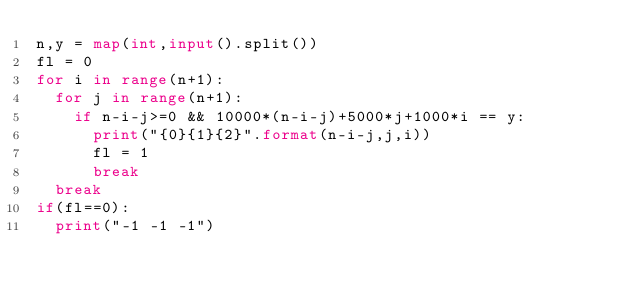Convert code to text. <code><loc_0><loc_0><loc_500><loc_500><_Python_>n,y = map(int,input().split())
fl = 0
for i in range(n+1):
  for j in range(n+1):
    if n-i-j>=0 && 10000*(n-i-j)+5000*j+1000*i == y:
      print("{0}{1}{2}".format(n-i-j,j,i))
      fl = 1
      break
  break
if(fl==0):
  print("-1 -1 -1")</code> 